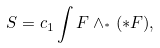Convert formula to latex. <formula><loc_0><loc_0><loc_500><loc_500>S = c _ { 1 } \int F \wedge _ { ^ { * } } ( * F ) ,</formula> 